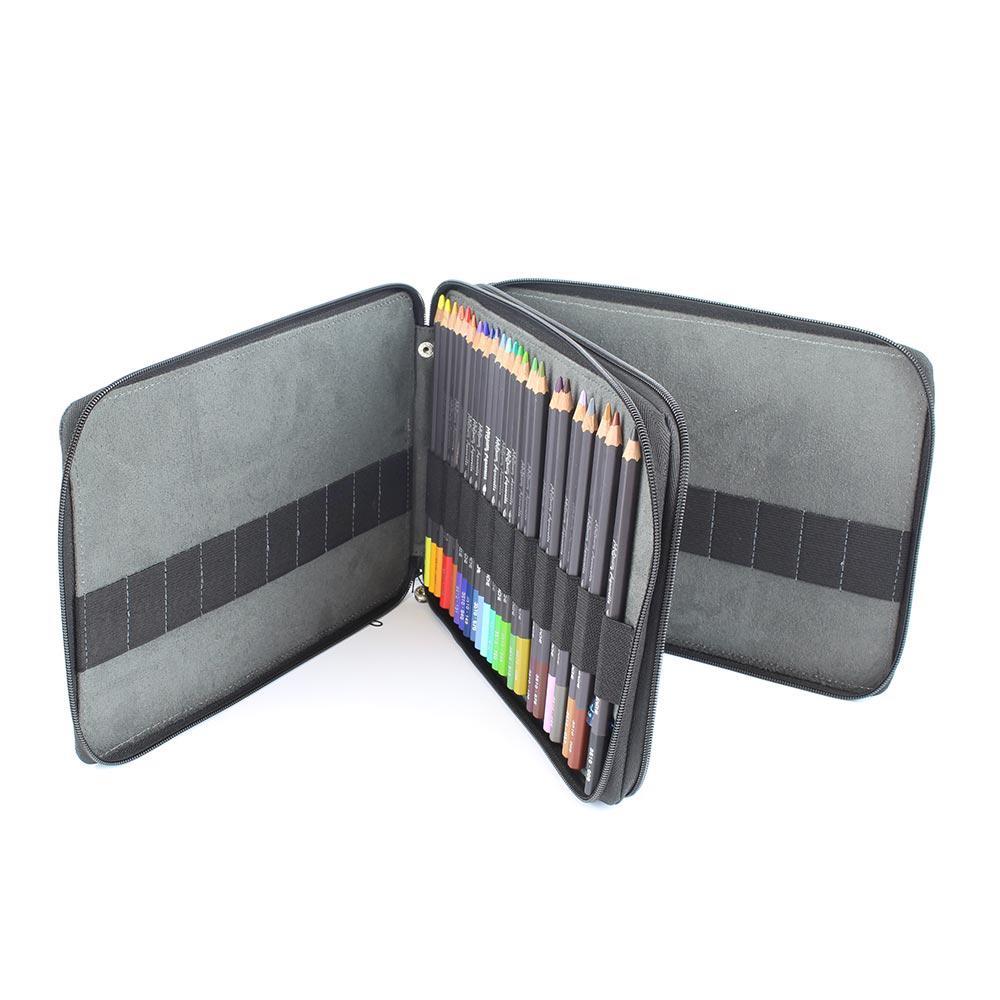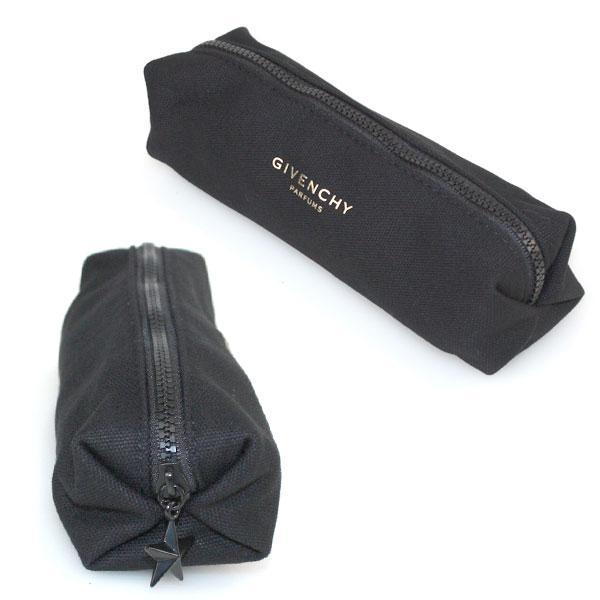The first image is the image on the left, the second image is the image on the right. Examine the images to the left and right. Is the description "The container in the image on the left is open." accurate? Answer yes or no. Yes. 